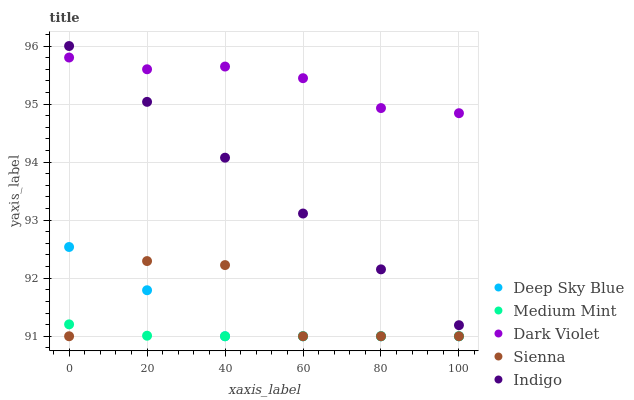Does Medium Mint have the minimum area under the curve?
Answer yes or no. Yes. Does Dark Violet have the maximum area under the curve?
Answer yes or no. Yes. Does Sienna have the minimum area under the curve?
Answer yes or no. No. Does Sienna have the maximum area under the curve?
Answer yes or no. No. Is Indigo the smoothest?
Answer yes or no. Yes. Is Sienna the roughest?
Answer yes or no. Yes. Is Sienna the smoothest?
Answer yes or no. No. Is Indigo the roughest?
Answer yes or no. No. Does Medium Mint have the lowest value?
Answer yes or no. Yes. Does Indigo have the lowest value?
Answer yes or no. No. Does Indigo have the highest value?
Answer yes or no. Yes. Does Sienna have the highest value?
Answer yes or no. No. Is Deep Sky Blue less than Dark Violet?
Answer yes or no. Yes. Is Indigo greater than Medium Mint?
Answer yes or no. Yes. Does Indigo intersect Dark Violet?
Answer yes or no. Yes. Is Indigo less than Dark Violet?
Answer yes or no. No. Is Indigo greater than Dark Violet?
Answer yes or no. No. Does Deep Sky Blue intersect Dark Violet?
Answer yes or no. No. 